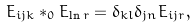<formula> <loc_0><loc_0><loc_500><loc_500>E _ { i j k } * _ { 0 } E _ { \ln r } = \delta _ { k l } \delta _ { j n } E _ { i j r } ,</formula> 